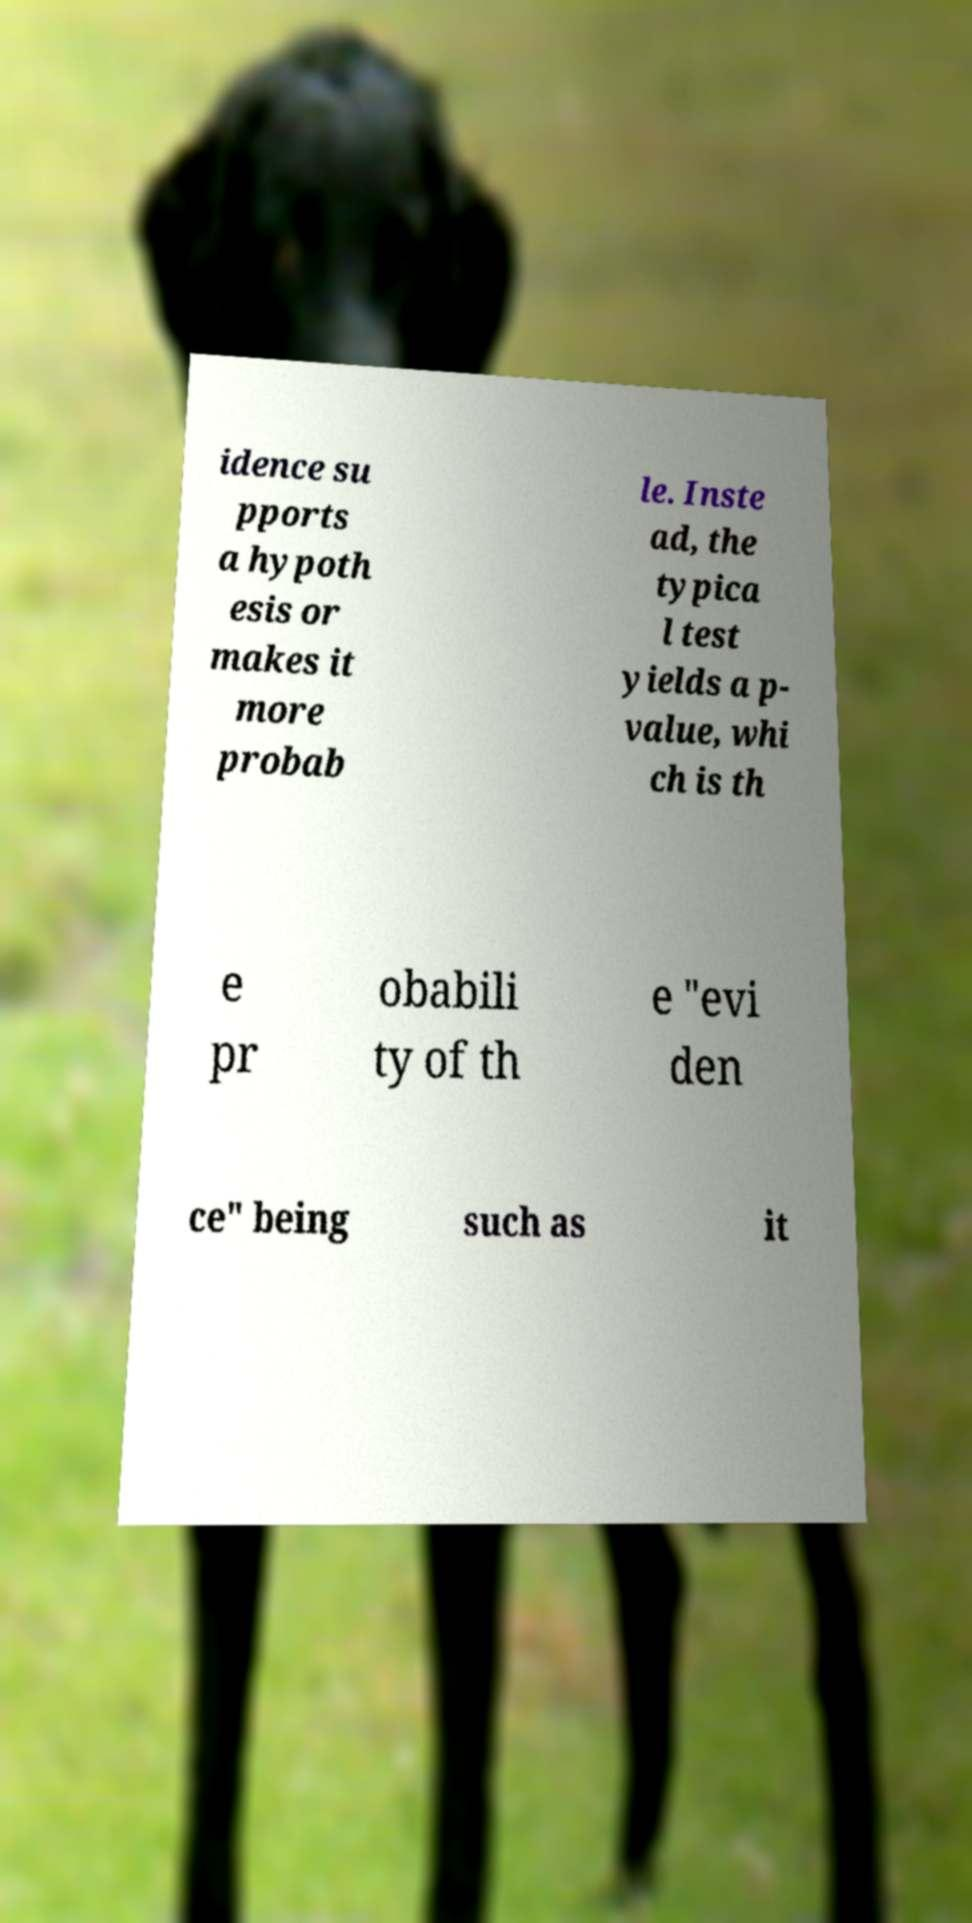Can you read and provide the text displayed in the image?This photo seems to have some interesting text. Can you extract and type it out for me? idence su pports a hypoth esis or makes it more probab le. Inste ad, the typica l test yields a p- value, whi ch is th e pr obabili ty of th e "evi den ce" being such as it 